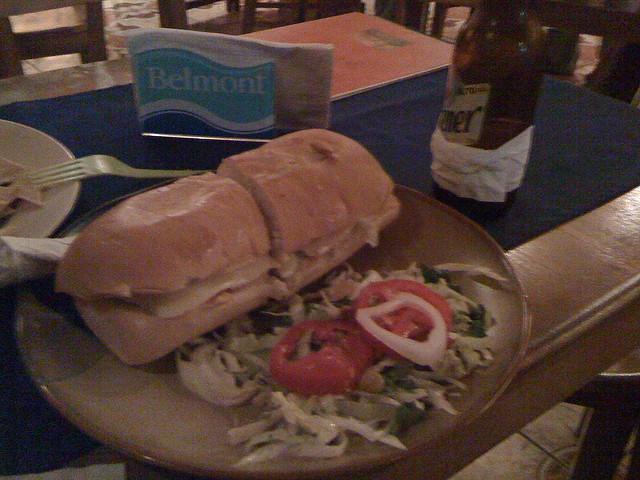Has the sandwich been cut in half?
Answer briefly. Yes. Is the utensil intended to be disposable?
Concise answer only. Yes. Which color is the tablecloth?
Be succinct. Blue. 